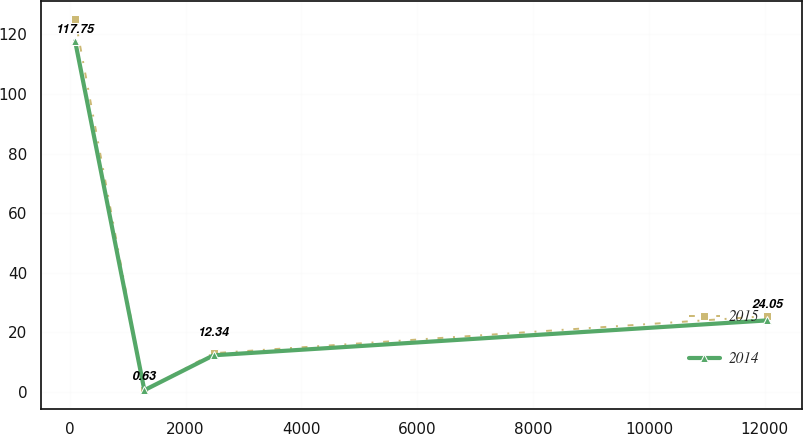Convert chart to OTSL. <chart><loc_0><loc_0><loc_500><loc_500><line_chart><ecel><fcel>2015<fcel>2014<nl><fcel>92.3<fcel>125.14<fcel>117.75<nl><fcel>1287.51<fcel>0.59<fcel>0.63<nl><fcel>2482.72<fcel>13.04<fcel>12.34<nl><fcel>12044.4<fcel>25.49<fcel>24.05<nl></chart> 